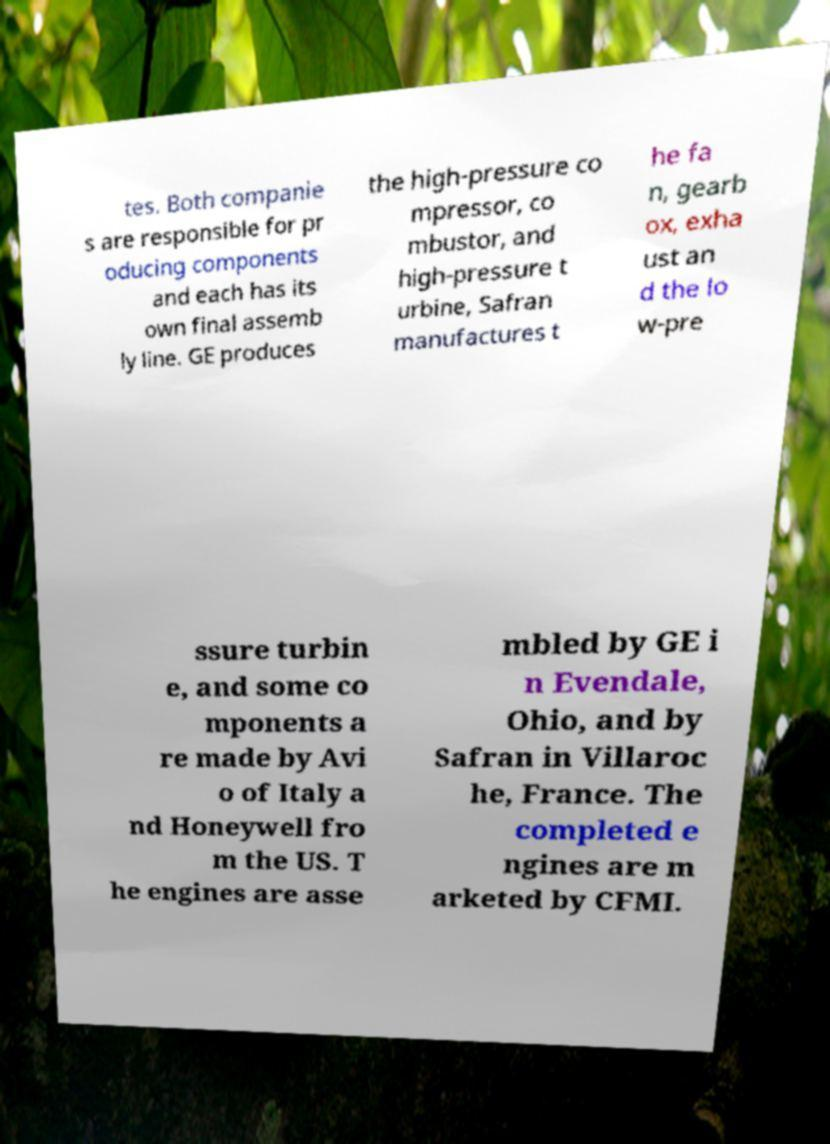Please identify and transcribe the text found in this image. tes. Both companie s are responsible for pr oducing components and each has its own final assemb ly line. GE produces the high-pressure co mpressor, co mbustor, and high-pressure t urbine, Safran manufactures t he fa n, gearb ox, exha ust an d the lo w-pre ssure turbin e, and some co mponents a re made by Avi o of Italy a nd Honeywell fro m the US. T he engines are asse mbled by GE i n Evendale, Ohio, and by Safran in Villaroc he, France. The completed e ngines are m arketed by CFMI. 